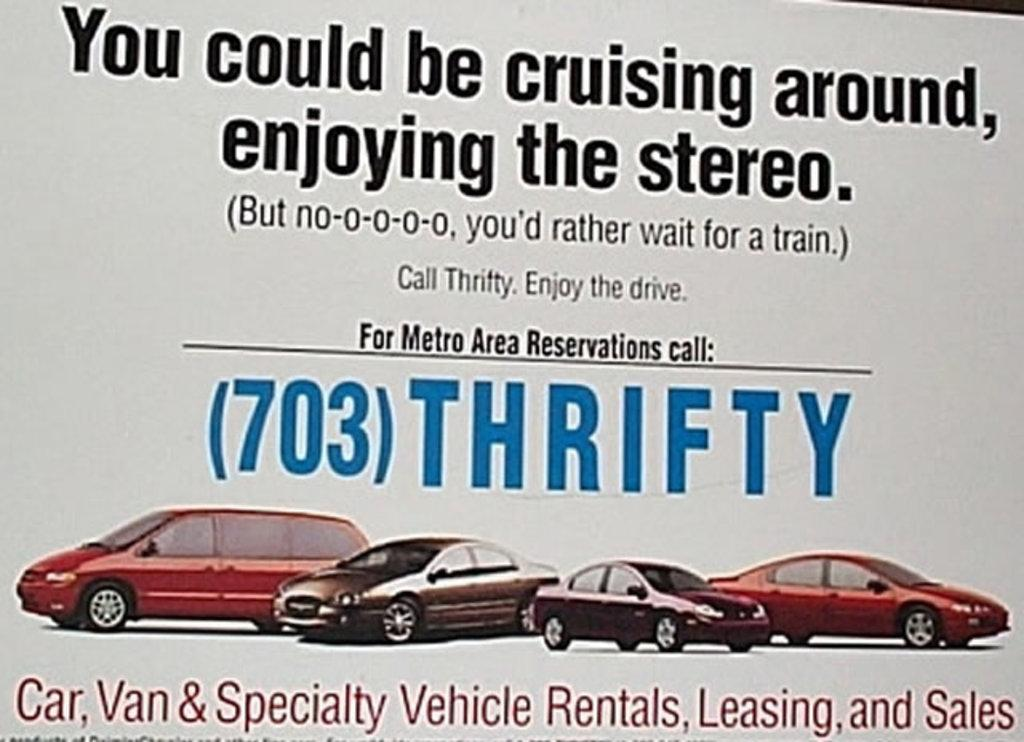What is present in the image that contains both images and text? There is a poster in the image that contains images and text. How many apples are depicted on the poster in the image? There is no apple present on the poster in the image. What type of boundary can be seen surrounding the poster in the image? There is no boundary surrounding the poster in the image. 